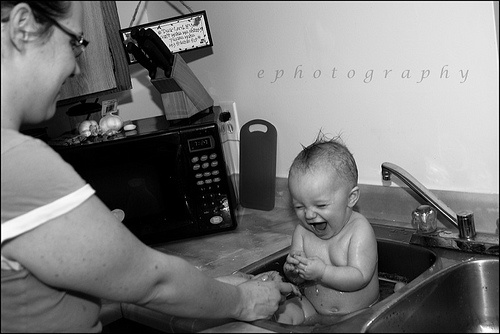Describe the objects in this image and their specific colors. I can see people in black, darkgray, gray, and lightgray tones, microwave in black, gray, and lightgray tones, sink in black, gray, darkgray, and lightgray tones, people in black, darkgray, gray, and lightgray tones, and knife in black, gray, lightgray, and darkgray tones in this image. 